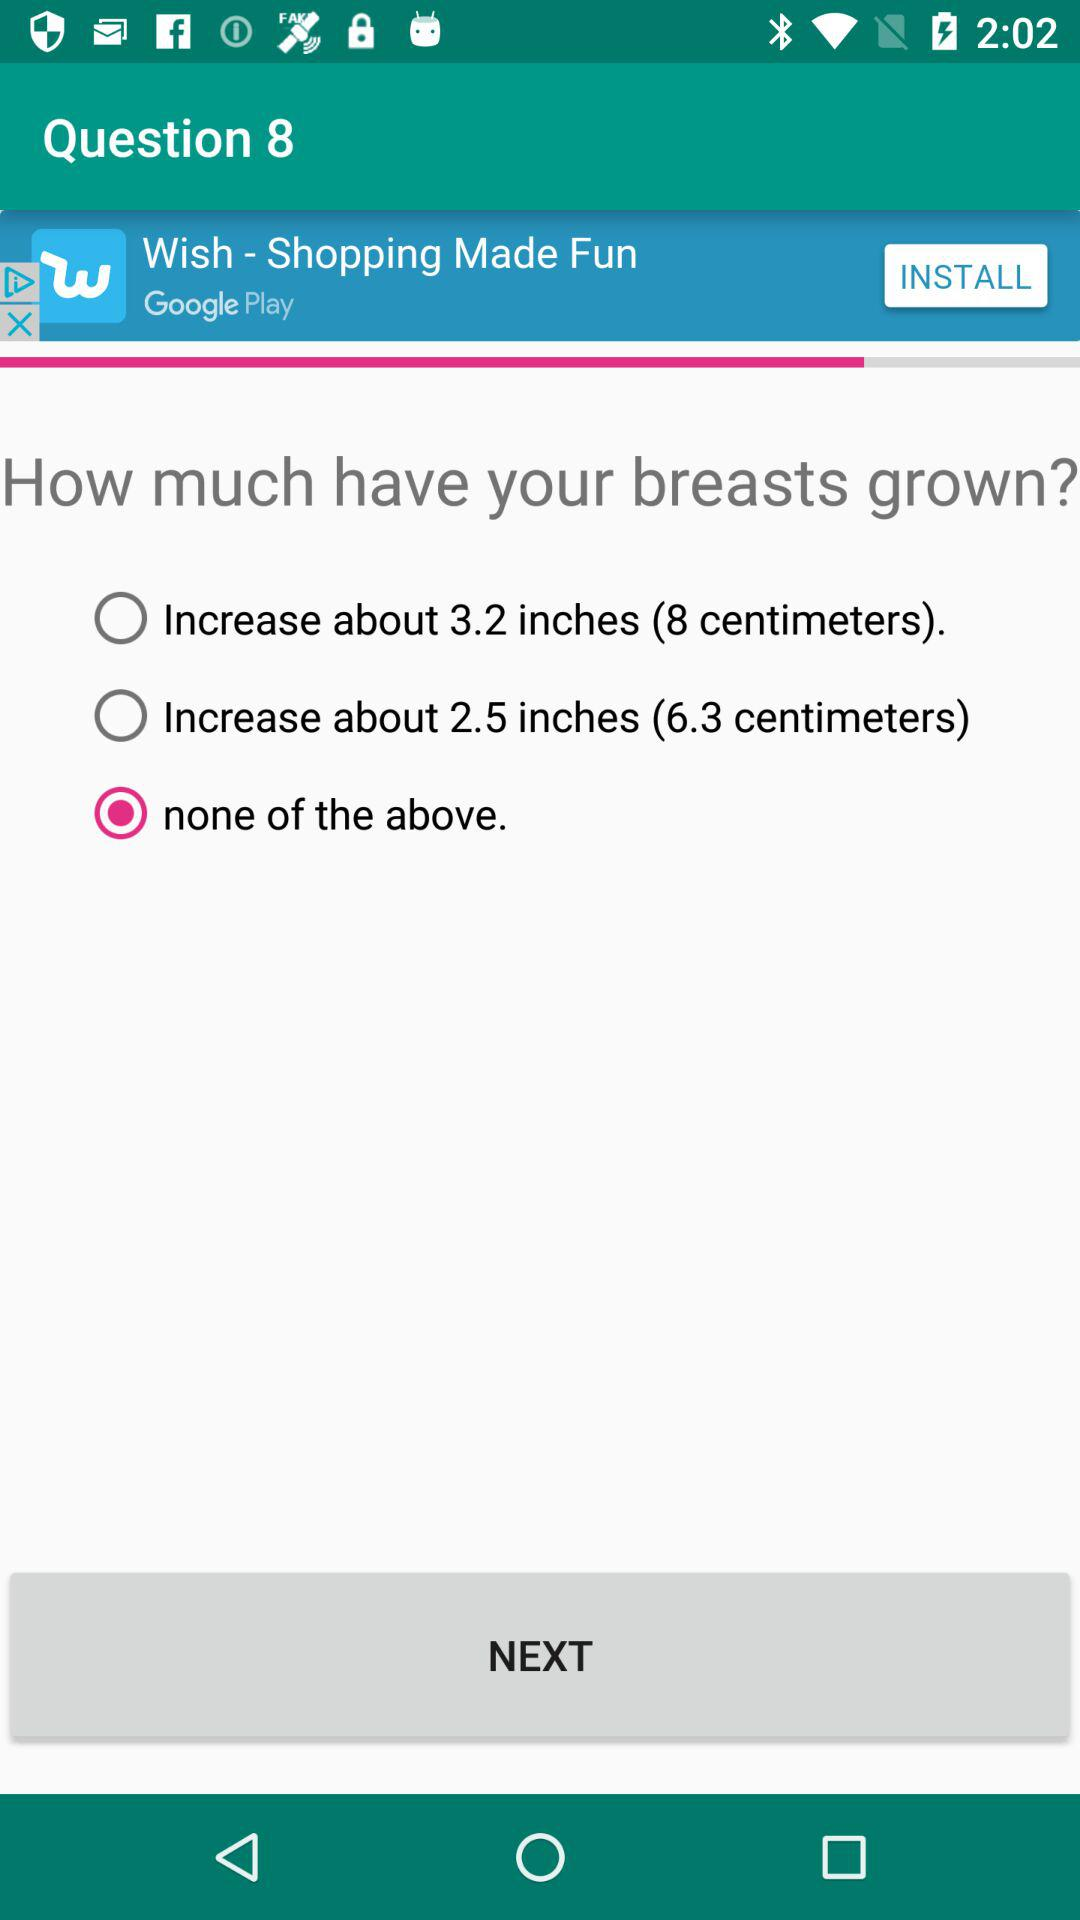How many centimeters is the difference between the increase in breast size options?
Answer the question using a single word or phrase. 1.7 